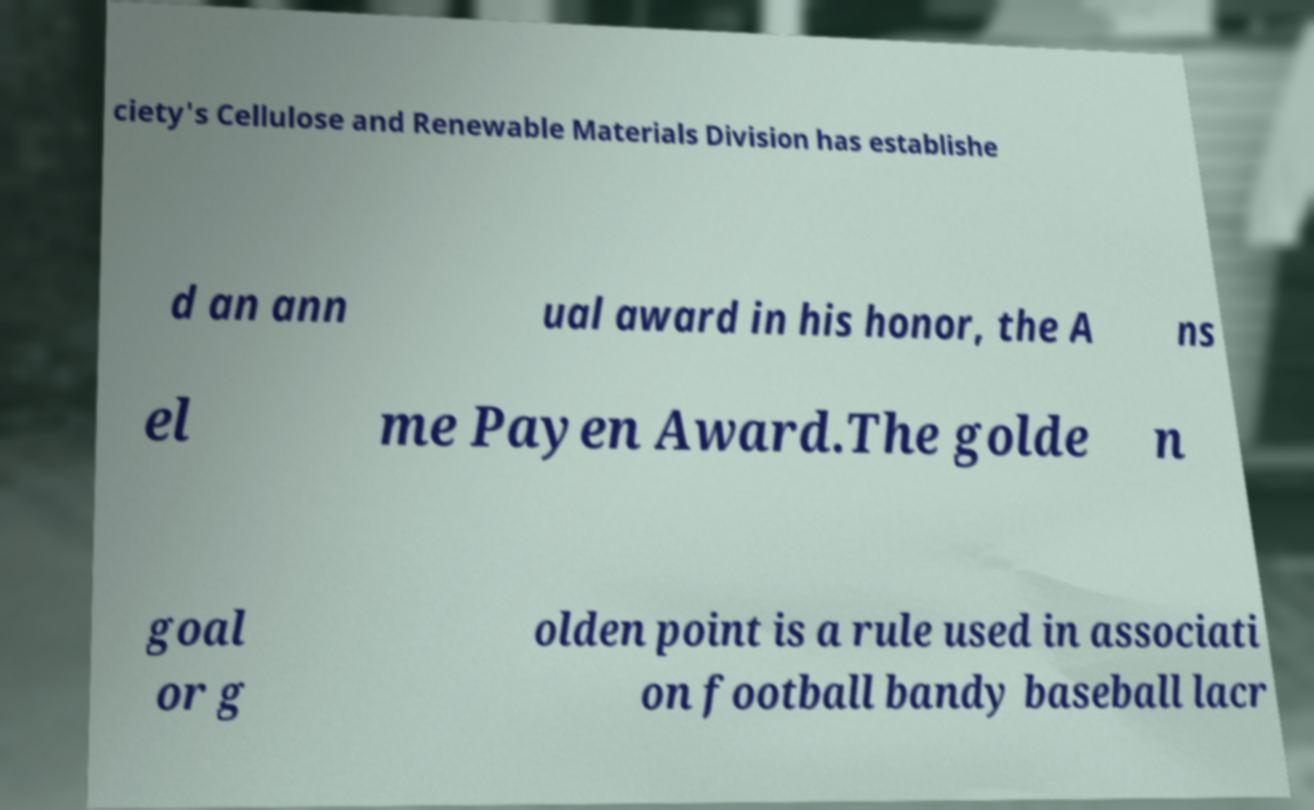What messages or text are displayed in this image? I need them in a readable, typed format. ciety's Cellulose and Renewable Materials Division has establishe d an ann ual award in his honor, the A ns el me Payen Award.The golde n goal or g olden point is a rule used in associati on football bandy baseball lacr 